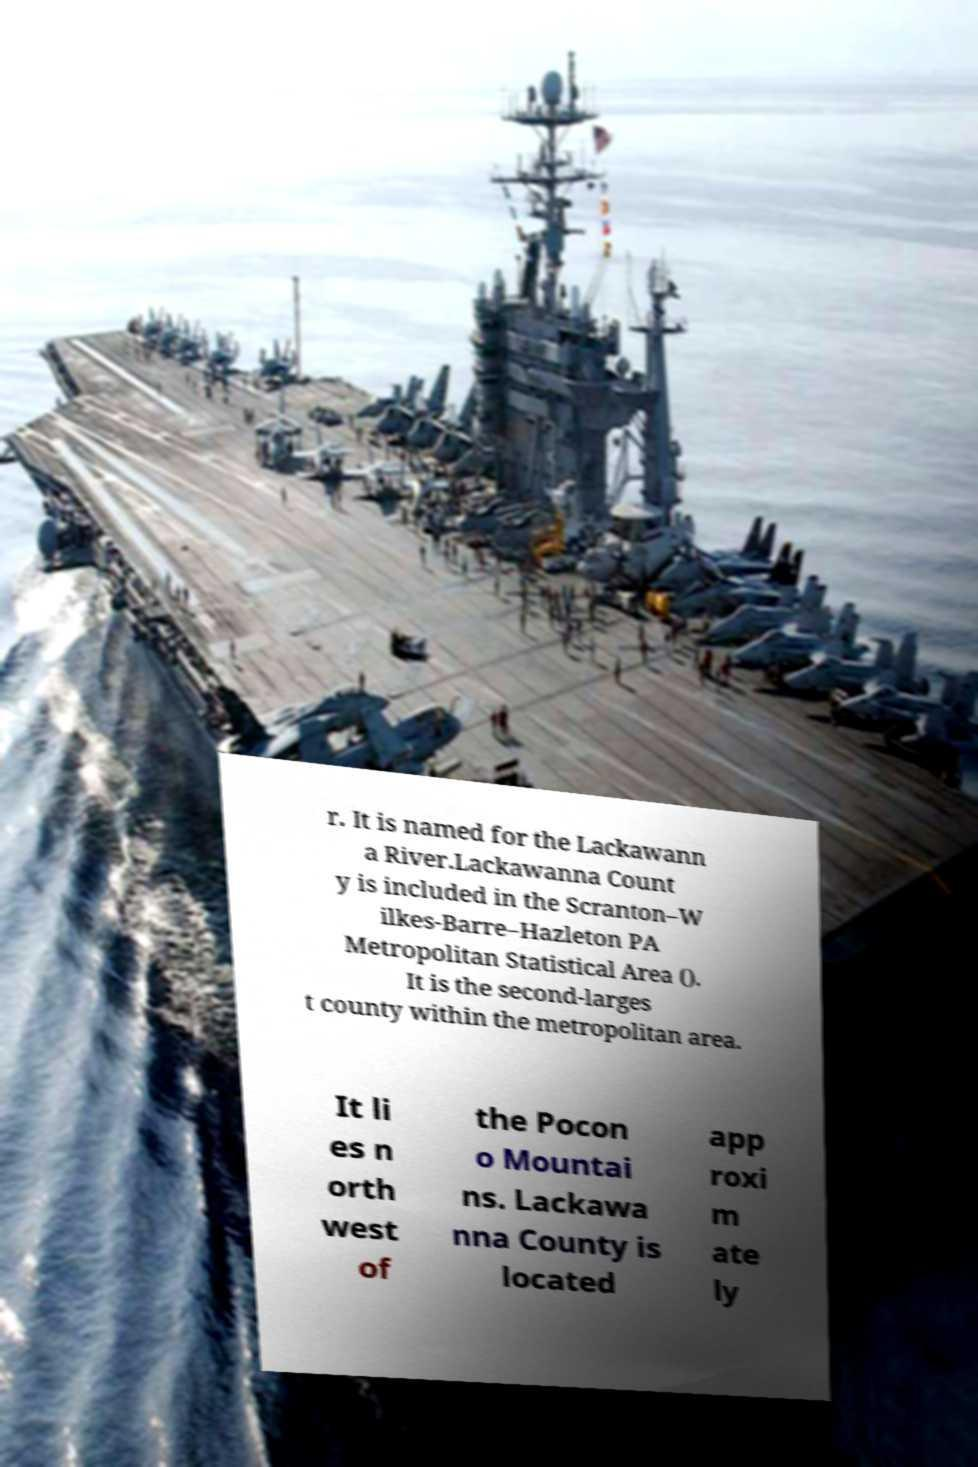Could you extract and type out the text from this image? r. It is named for the Lackawann a River.Lackawanna Count y is included in the Scranton–W ilkes-Barre–Hazleton PA Metropolitan Statistical Area (). It is the second-larges t county within the metropolitan area. It li es n orth west of the Pocon o Mountai ns. Lackawa nna County is located app roxi m ate ly 